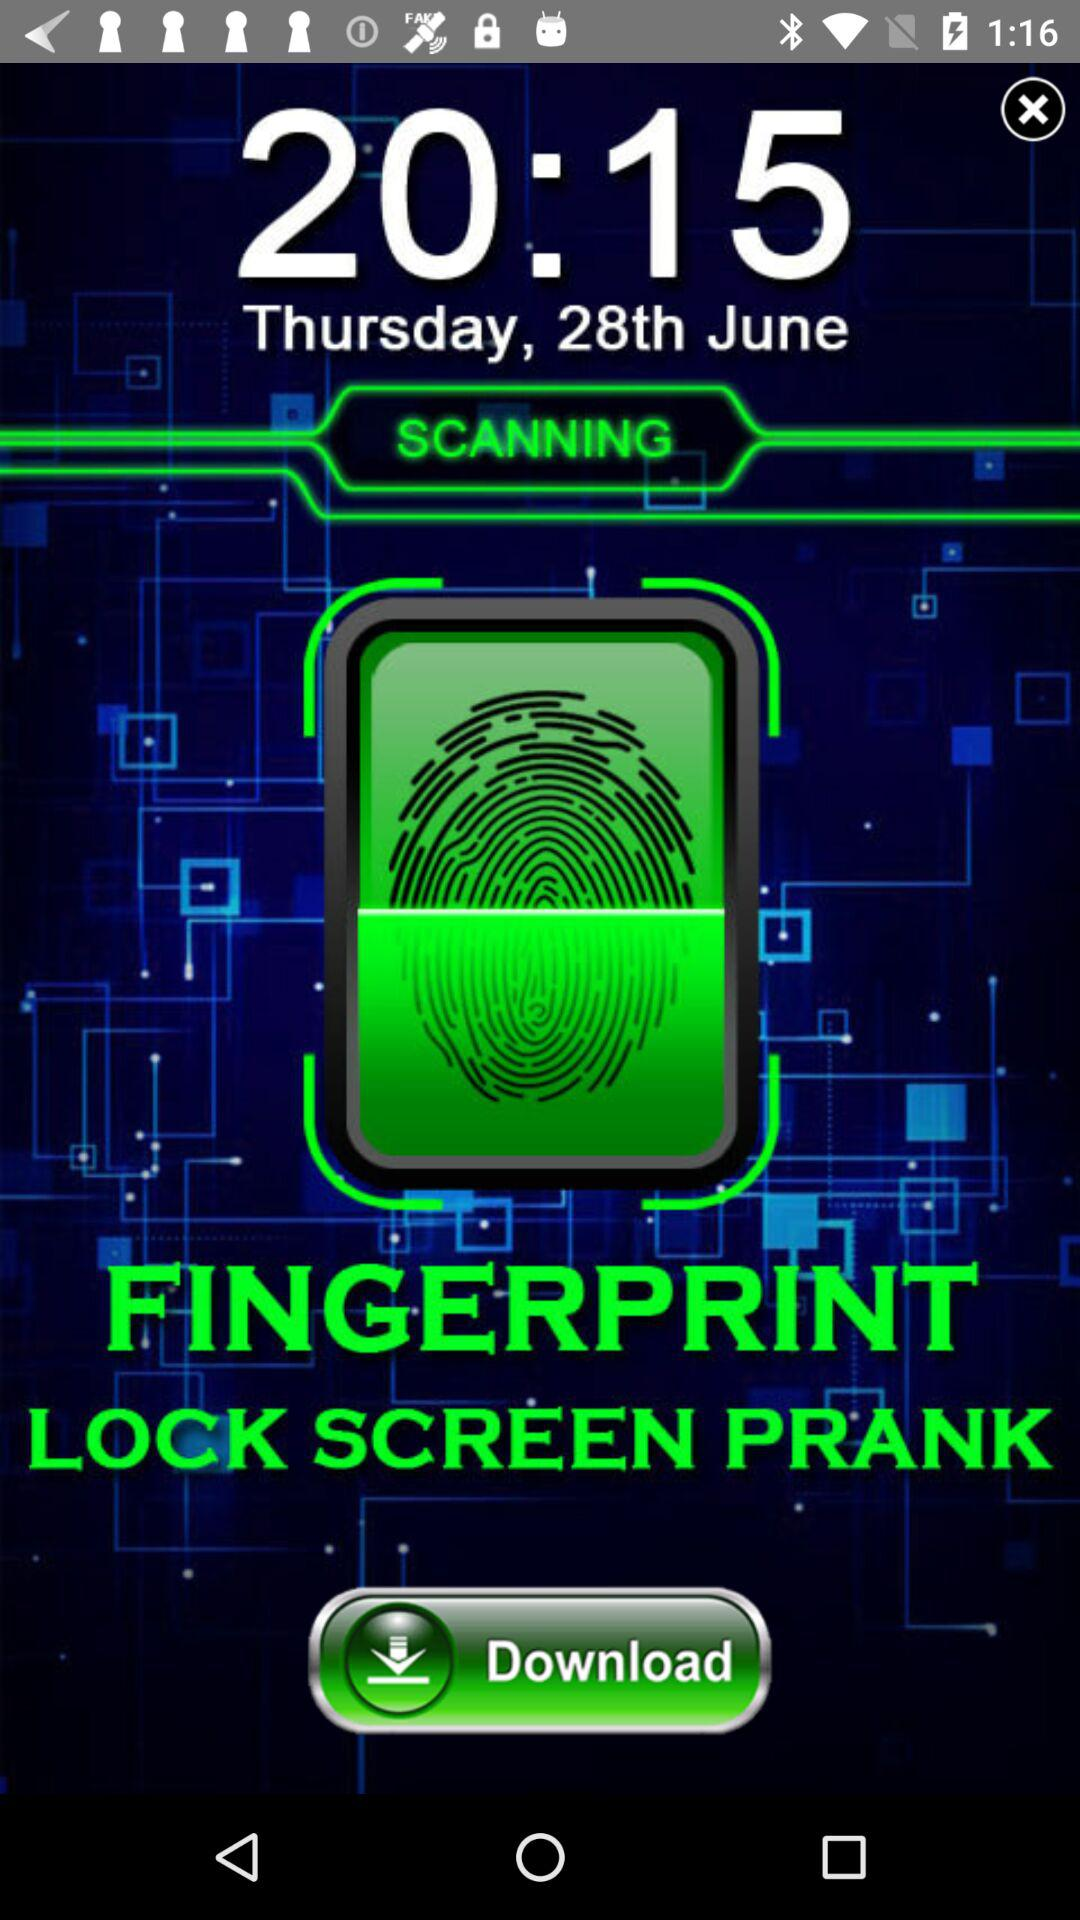What is the date? The date is Thursday, June 28. 